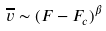Convert formula to latex. <formula><loc_0><loc_0><loc_500><loc_500>\overline { v } \sim ( F - F _ { c } ) ^ { \beta }</formula> 